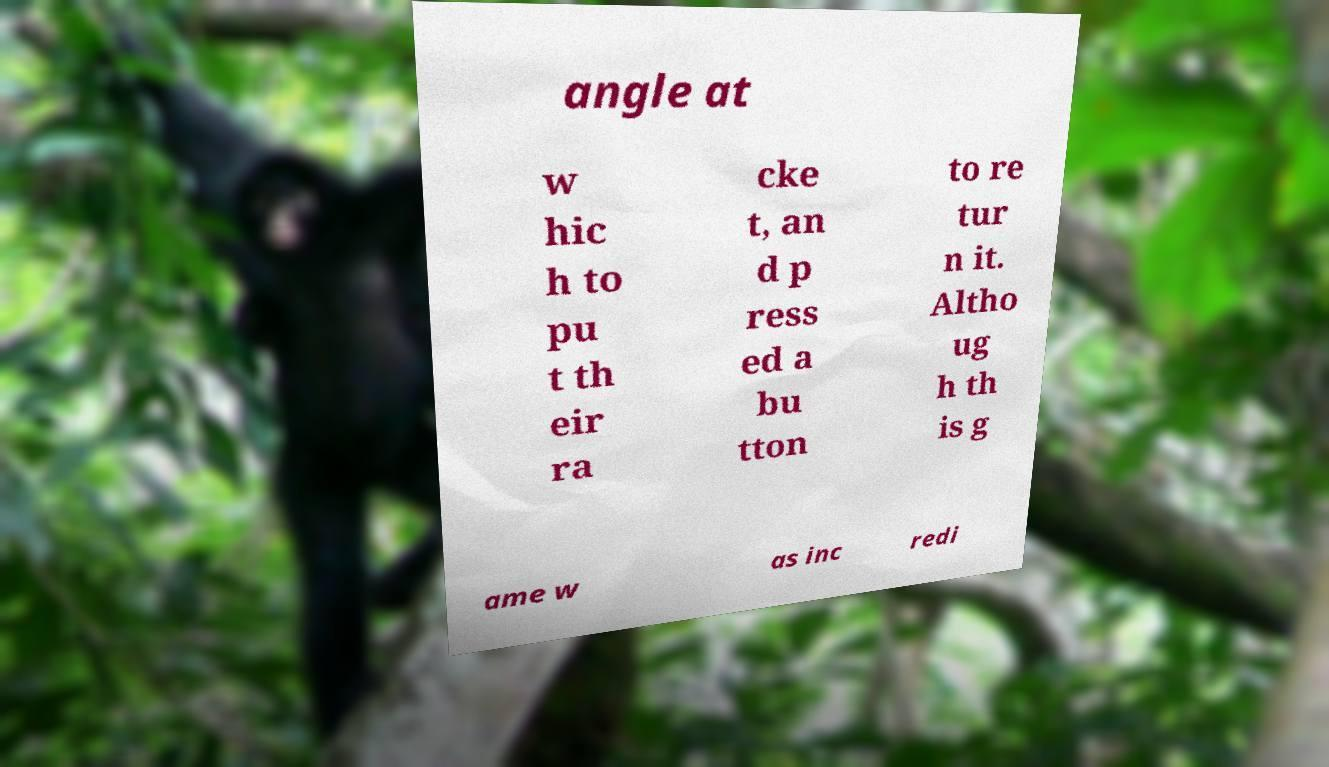Please read and relay the text visible in this image. What does it say? angle at w hic h to pu t th eir ra cke t, an d p ress ed a bu tton to re tur n it. Altho ug h th is g ame w as inc redi 